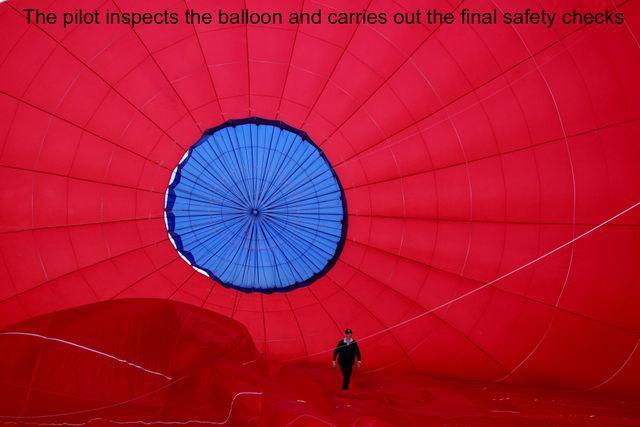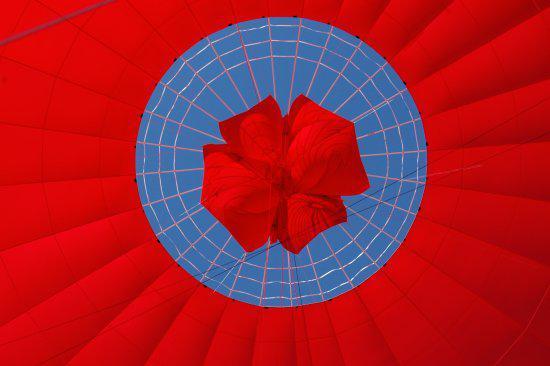The first image is the image on the left, the second image is the image on the right. For the images shown, is this caption "The fabric of the hot-air balloon in the left image features at least three colors." true? Answer yes or no. No. The first image is the image on the left, the second image is the image on the right. Examine the images to the left and right. Is the description "A blue circle design is at the top of the balloon on the right." accurate? Answer yes or no. Yes. 